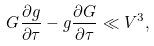<formula> <loc_0><loc_0><loc_500><loc_500>G \frac { \partial g } { \partial \tau } - g \frac { \partial G } { \partial \tau } \ll V ^ { 3 } ,</formula> 